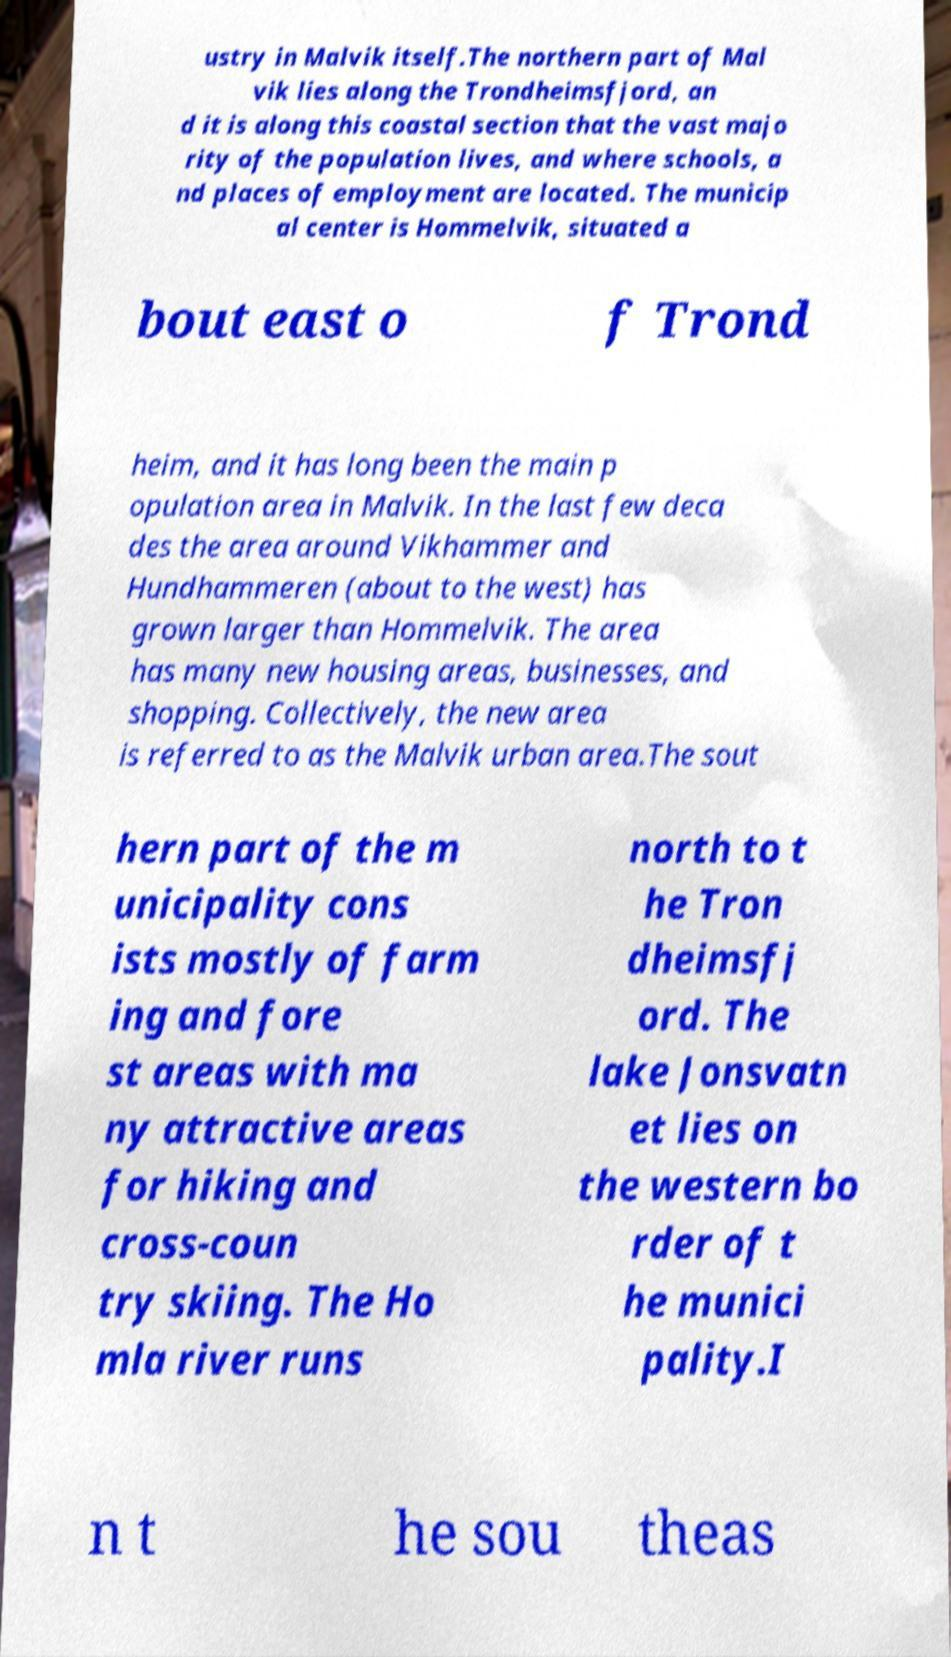Please read and relay the text visible in this image. What does it say? ustry in Malvik itself.The northern part of Mal vik lies along the Trondheimsfjord, an d it is along this coastal section that the vast majo rity of the population lives, and where schools, a nd places of employment are located. The municip al center is Hommelvik, situated a bout east o f Trond heim, and it has long been the main p opulation area in Malvik. In the last few deca des the area around Vikhammer and Hundhammeren (about to the west) has grown larger than Hommelvik. The area has many new housing areas, businesses, and shopping. Collectively, the new area is referred to as the Malvik urban area.The sout hern part of the m unicipality cons ists mostly of farm ing and fore st areas with ma ny attractive areas for hiking and cross-coun try skiing. The Ho mla river runs north to t he Tron dheimsfj ord. The lake Jonsvatn et lies on the western bo rder of t he munici pality.I n t he sou theas 